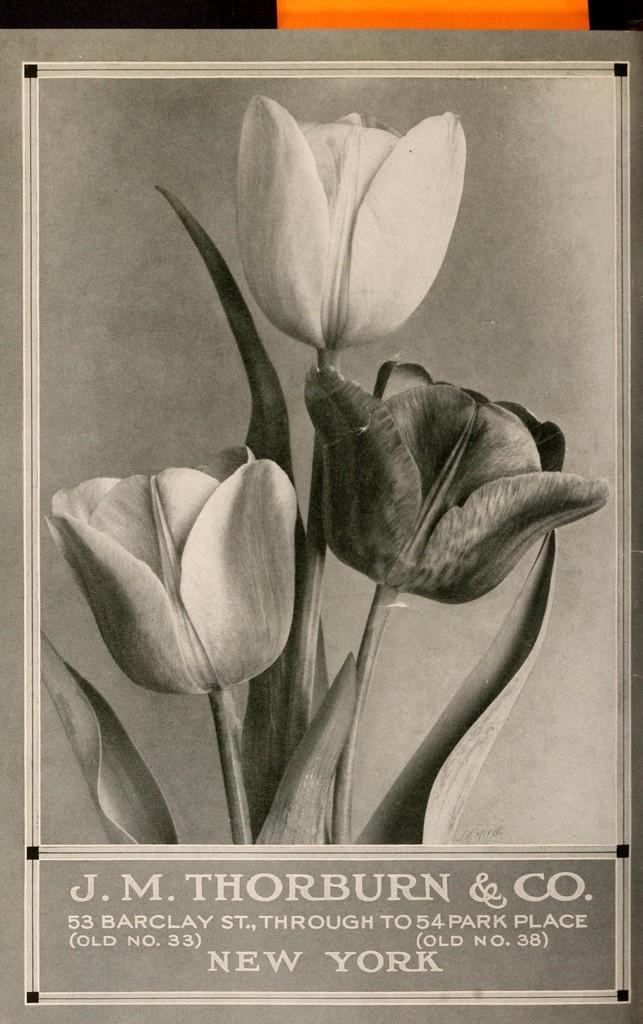Can you describe this image briefly? This is a black and white image as we can see there are some flowers in the middle of this image and there is some text written in the bottom of this image. 